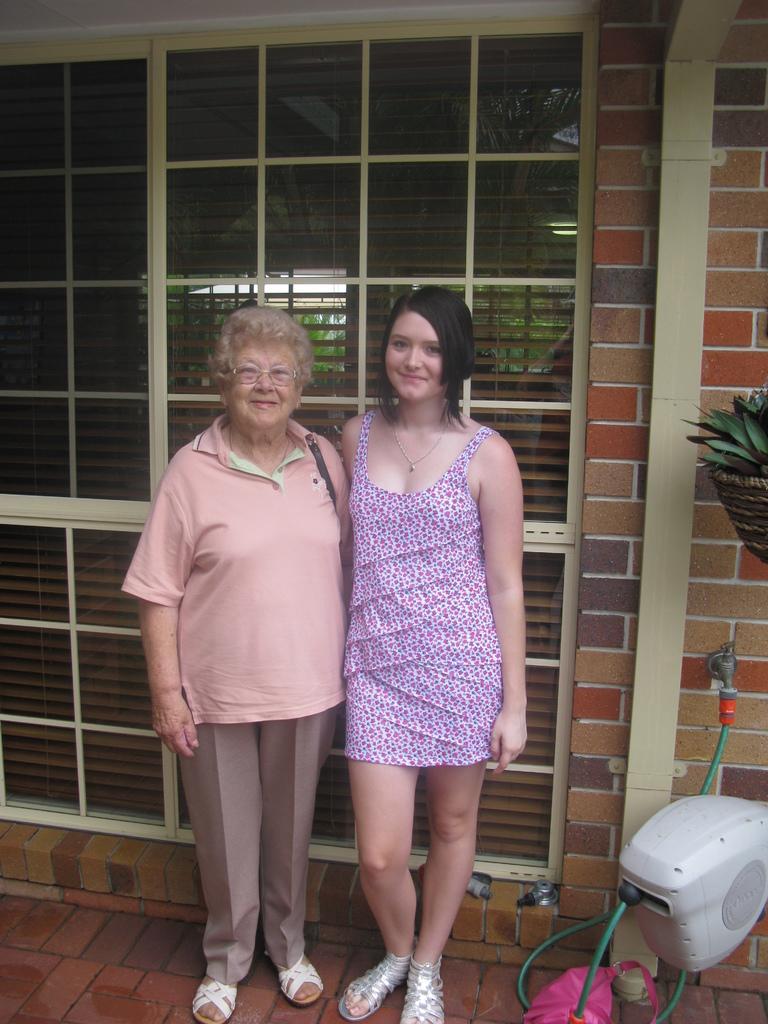Describe this image in one or two sentences. In this image there are two persons standing in the center and smiling. On the right side there is an object which is white in colour and in the background there is a door and on the right side there is a wall and there is a plant. 